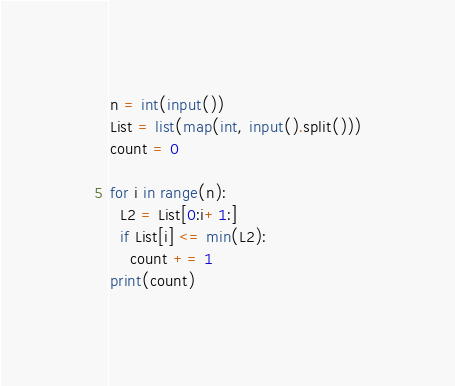Convert code to text. <code><loc_0><loc_0><loc_500><loc_500><_Python_>n = int(input())
List = list(map(int, input().split()))
count = 0

for i in range(n):
  L2 = List[0:i+1:]
  if List[i] <= min(L2):
    count += 1
print(count)</code> 